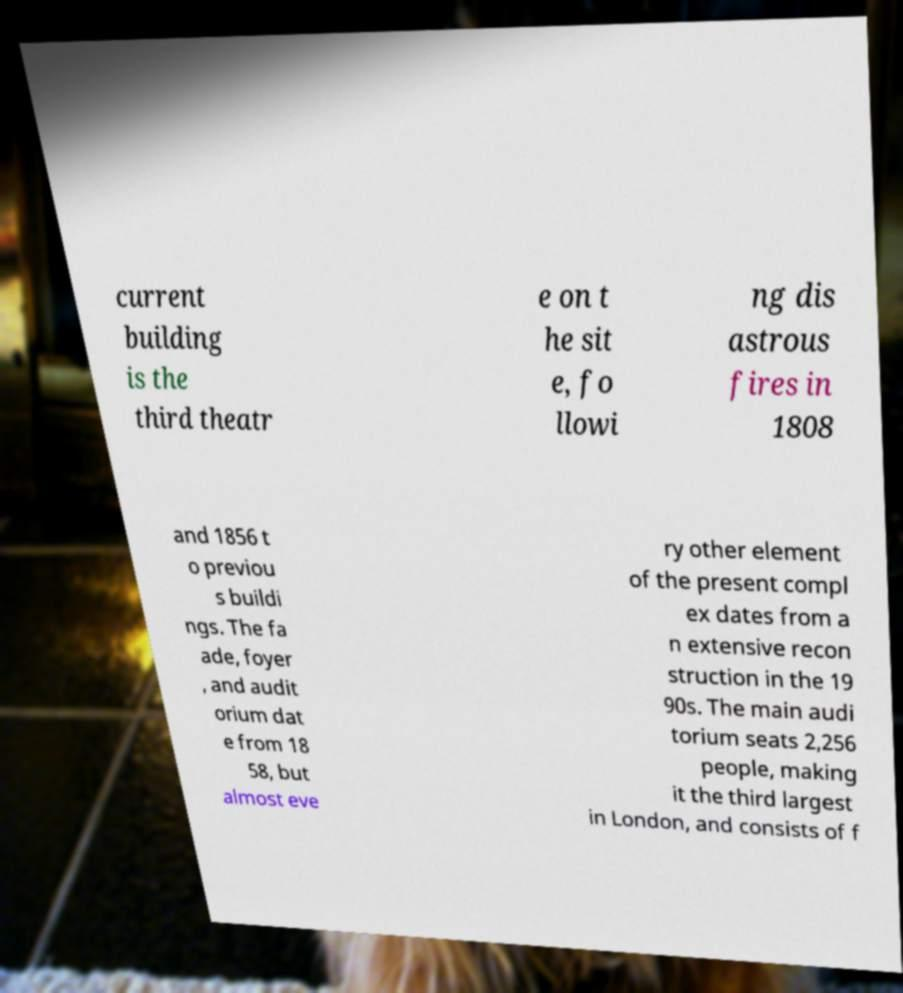For documentation purposes, I need the text within this image transcribed. Could you provide that? current building is the third theatr e on t he sit e, fo llowi ng dis astrous fires in 1808 and 1856 t o previou s buildi ngs. The fa ade, foyer , and audit orium dat e from 18 58, but almost eve ry other element of the present compl ex dates from a n extensive recon struction in the 19 90s. The main audi torium seats 2,256 people, making it the third largest in London, and consists of f 